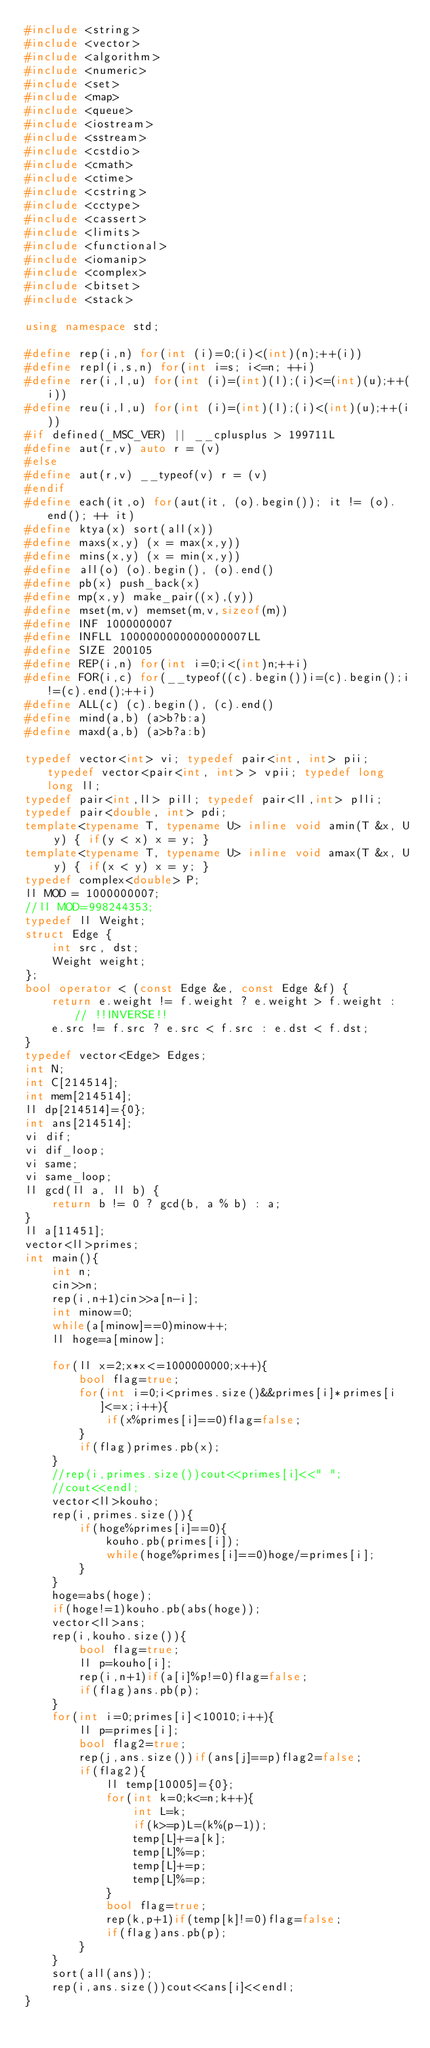Convert code to text. <code><loc_0><loc_0><loc_500><loc_500><_C++_>#include <string>
#include <vector>
#include <algorithm>
#include <numeric>
#include <set>
#include <map>
#include <queue>
#include <iostream>
#include <sstream>
#include <cstdio>
#include <cmath>
#include <ctime>
#include <cstring>
#include <cctype>
#include <cassert>
#include <limits>
#include <functional>
#include <iomanip>
#include <complex>
#include <bitset>
#include <stack>
 
using namespace std;
 
#define rep(i,n) for(int (i)=0;(i)<(int)(n);++(i))
#define repl(i,s,n) for(int i=s; i<=n; ++i)
#define rer(i,l,u) for(int (i)=(int)(l);(i)<=(int)(u);++(i))
#define reu(i,l,u) for(int (i)=(int)(l);(i)<(int)(u);++(i))
#if defined(_MSC_VER) || __cplusplus > 199711L
#define aut(r,v) auto r = (v)
#else
#define aut(r,v) __typeof(v) r = (v)
#endif
#define each(it,o) for(aut(it, (o).begin()); it != (o).end(); ++ it)
#define ktya(x) sort(all(x))
#define maxs(x,y) (x = max(x,y))
#define mins(x,y) (x = min(x,y))
#define all(o) (o).begin(), (o).end()
#define pb(x) push_back(x)
#define mp(x,y) make_pair((x),(y))
#define mset(m,v) memset(m,v,sizeof(m))
#define INF 1000000007
#define INFLL 1000000000000000007LL
#define SIZE 200105
#define REP(i,n) for(int i=0;i<(int)n;++i)
#define FOR(i,c) for(__typeof((c).begin())i=(c).begin();i!=(c).end();++i)
#define ALL(c) (c).begin(), (c).end()
#define mind(a,b) (a>b?b:a)
#define maxd(a,b) (a>b?a:b)

typedef vector<int> vi; typedef pair<int, int> pii; typedef vector<pair<int, int> > vpii; typedef long long ll;
typedef pair<int,ll> pill; typedef pair<ll,int> plli; 
typedef pair<double, int> pdi;
template<typename T, typename U> inline void amin(T &x, U y) { if(y < x) x = y; }
template<typename T, typename U> inline void amax(T &x, U y) { if(x < y) x = y; }
typedef complex<double> P;
ll MOD = 1000000007;
//ll MOD=998244353;
typedef ll Weight;
struct Edge {
	int src, dst;
	Weight weight;
};
bool operator < (const Edge &e, const Edge &f) {
	return e.weight != f.weight ? e.weight > f.weight : // !!INVERSE!!
	e.src != f.src ? e.src < f.src : e.dst < f.dst;
}
typedef vector<Edge> Edges;
int N;
int C[214514];
int mem[214514];
ll dp[214514]={0};
int ans[214514];
vi dif;
vi dif_loop;
vi same;
vi same_loop;
ll gcd(ll a, ll b) {
	return b != 0 ? gcd(b, a % b) : a;
}
ll a[11451];
vector<ll>primes;
int main(){
	int n;
	cin>>n;
	rep(i,n+1)cin>>a[n-i];
	int minow=0;
	while(a[minow]==0)minow++;
	ll hoge=a[minow];
	
	for(ll x=2;x*x<=1000000000;x++){
		bool flag=true;
		for(int i=0;i<primes.size()&&primes[i]*primes[i]<=x;i++){
			if(x%primes[i]==0)flag=false;
		}
		if(flag)primes.pb(x);
	}
	//rep(i,primes.size())cout<<primes[i]<<" ";
	//cout<<endl;
	vector<ll>kouho;
	rep(i,primes.size()){
		if(hoge%primes[i]==0){
			kouho.pb(primes[i]);
			while(hoge%primes[i]==0)hoge/=primes[i];
		}
	}
	hoge=abs(hoge);
	if(hoge!=1)kouho.pb(abs(hoge));
	vector<ll>ans;
	rep(i,kouho.size()){
		bool flag=true;
		ll p=kouho[i];
		rep(i,n+1)if(a[i]%p!=0)flag=false;
		if(flag)ans.pb(p);
	}
	for(int i=0;primes[i]<10010;i++){
		ll p=primes[i];
		bool flag2=true;
		rep(j,ans.size())if(ans[j]==p)flag2=false;
		if(flag2){
			ll temp[10005]={0};
			for(int k=0;k<=n;k++){
				int L=k;
				if(k>=p)L=(k%(p-1));
				temp[L]+=a[k];
				temp[L]%=p;
				temp[L]+=p;
				temp[L]%=p;
			}
			bool flag=true;
			rep(k,p+1)if(temp[k]!=0)flag=false;
			if(flag)ans.pb(p);
		}
	}
	sort(all(ans));
	rep(i,ans.size())cout<<ans[i]<<endl;
}</code> 